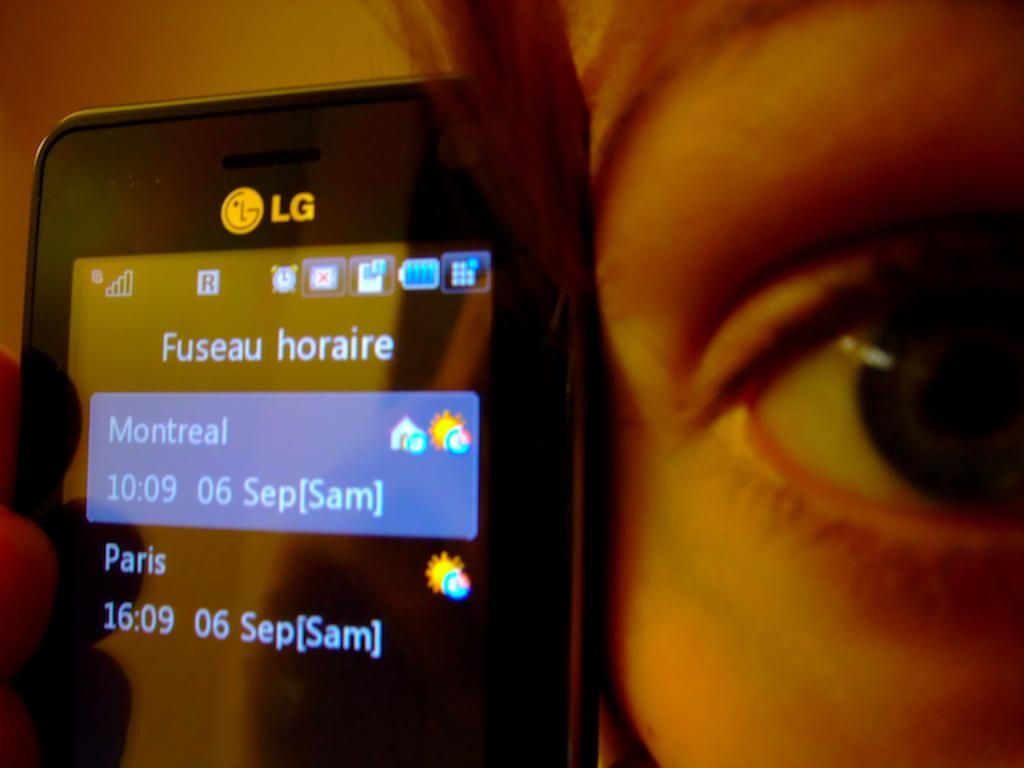What electronic device is present in the image? There is a mobile phone in the image. Where is the mobile phone located in relation to a person? The mobile phone is near a person's face. What can be seen on the mobile phone's screen? There is text visible on the mobile phone's screen. What type of stone is being coughed up by the visitor in the image? There is no stone or visitor present in the image; it only features a mobile phone near a person's face. 